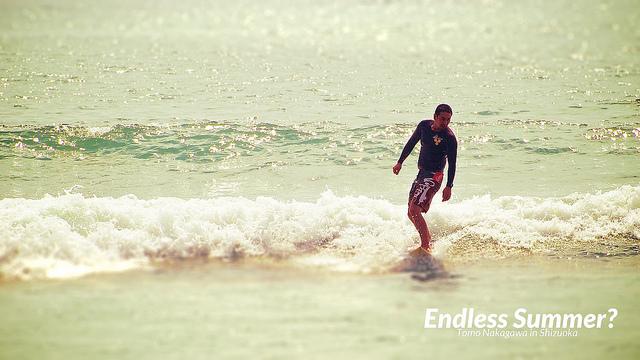Does the surfer have long hair?
Give a very brief answer. No. Is that a high wave?
Quick response, please. No. Is the surfer facing the beach?
Short answer required. Yes. 